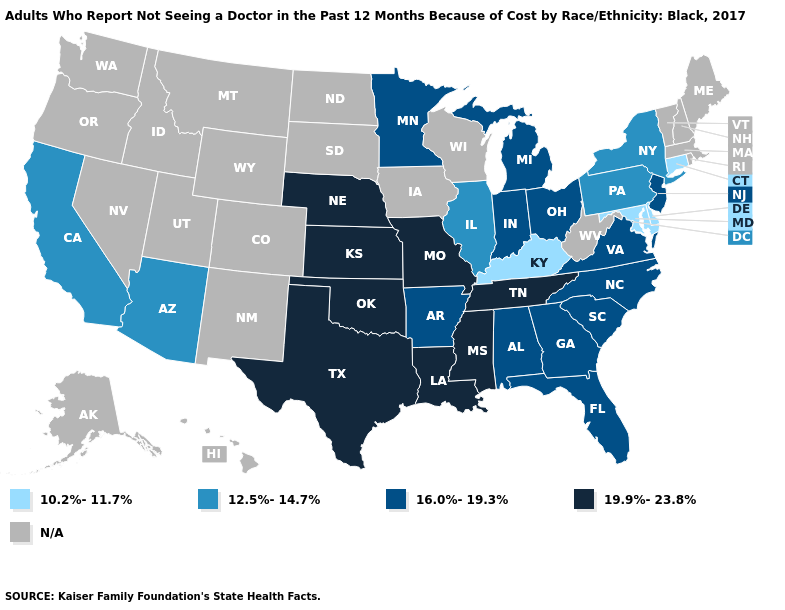Among the states that border Texas , does Oklahoma have the highest value?
Write a very short answer. Yes. What is the value of Kansas?
Answer briefly. 19.9%-23.8%. What is the lowest value in the USA?
Write a very short answer. 10.2%-11.7%. Name the states that have a value in the range 10.2%-11.7%?
Write a very short answer. Connecticut, Delaware, Kentucky, Maryland. What is the value of Colorado?
Concise answer only. N/A. Name the states that have a value in the range 16.0%-19.3%?
Short answer required. Alabama, Arkansas, Florida, Georgia, Indiana, Michigan, Minnesota, New Jersey, North Carolina, Ohio, South Carolina, Virginia. What is the value of Pennsylvania?
Give a very brief answer. 12.5%-14.7%. Does New Jersey have the highest value in the Northeast?
Answer briefly. Yes. What is the value of Nevada?
Short answer required. N/A. Name the states that have a value in the range 16.0%-19.3%?
Quick response, please. Alabama, Arkansas, Florida, Georgia, Indiana, Michigan, Minnesota, New Jersey, North Carolina, Ohio, South Carolina, Virginia. What is the value of Tennessee?
Short answer required. 19.9%-23.8%. Name the states that have a value in the range N/A?
Answer briefly. Alaska, Colorado, Hawaii, Idaho, Iowa, Maine, Massachusetts, Montana, Nevada, New Hampshire, New Mexico, North Dakota, Oregon, Rhode Island, South Dakota, Utah, Vermont, Washington, West Virginia, Wisconsin, Wyoming. Which states have the highest value in the USA?
Keep it brief. Kansas, Louisiana, Mississippi, Missouri, Nebraska, Oklahoma, Tennessee, Texas. What is the value of Wyoming?
Short answer required. N/A. Name the states that have a value in the range N/A?
Give a very brief answer. Alaska, Colorado, Hawaii, Idaho, Iowa, Maine, Massachusetts, Montana, Nevada, New Hampshire, New Mexico, North Dakota, Oregon, Rhode Island, South Dakota, Utah, Vermont, Washington, West Virginia, Wisconsin, Wyoming. 